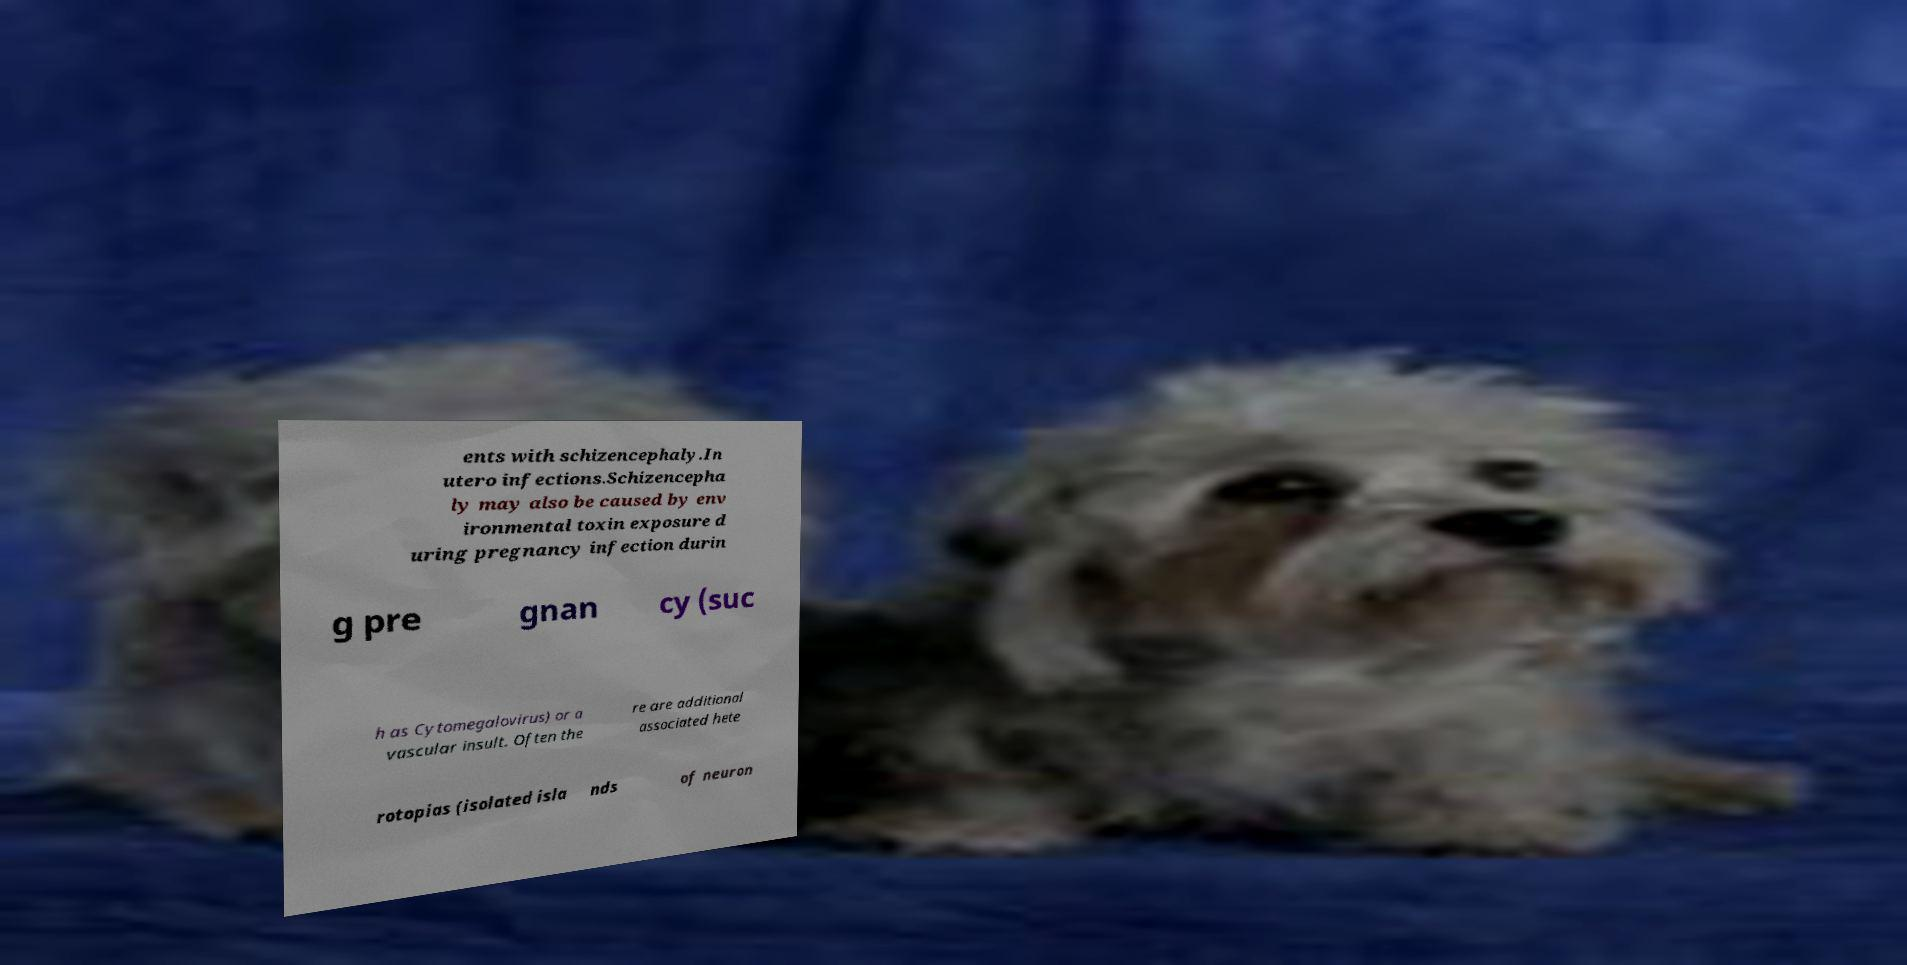Could you extract and type out the text from this image? ents with schizencephaly.In utero infections.Schizencepha ly may also be caused by env ironmental toxin exposure d uring pregnancy infection durin g pre gnan cy (suc h as Cytomegalovirus) or a vascular insult. Often the re are additional associated hete rotopias (isolated isla nds of neuron 